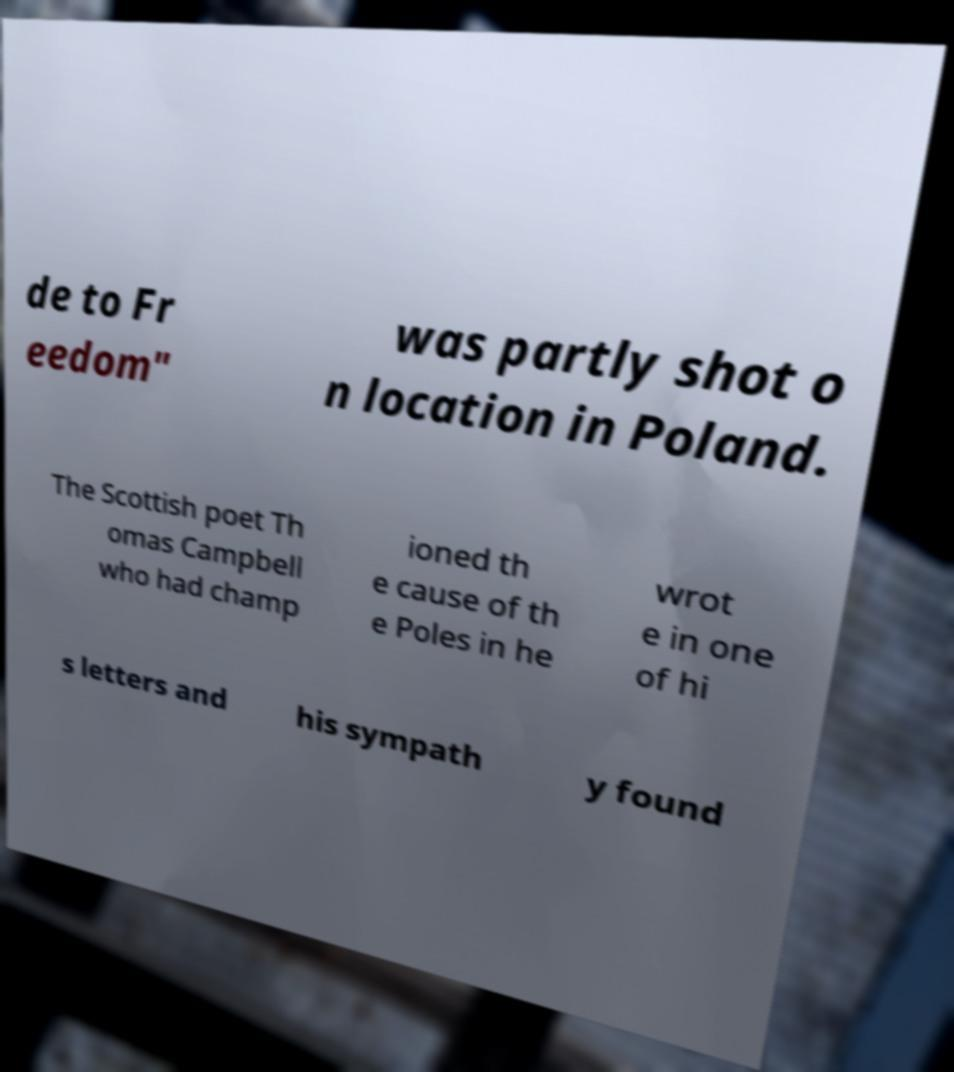Can you accurately transcribe the text from the provided image for me? de to Fr eedom" was partly shot o n location in Poland. The Scottish poet Th omas Campbell who had champ ioned th e cause of th e Poles in he wrot e in one of hi s letters and his sympath y found 